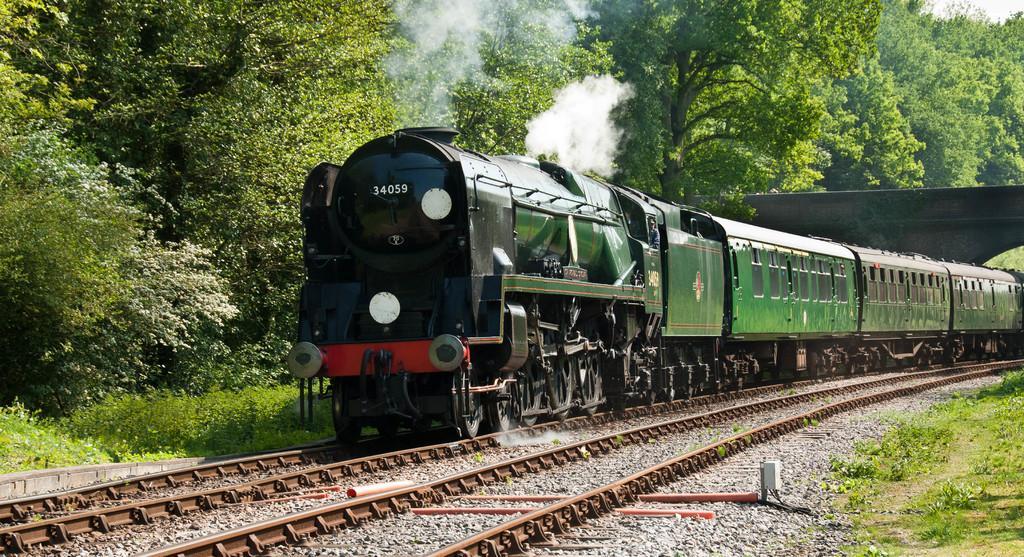How would you summarize this image in a sentence or two? In this image we can see there is a train on the railway track and at the back we can see the bridge. And there are trees and plants. 